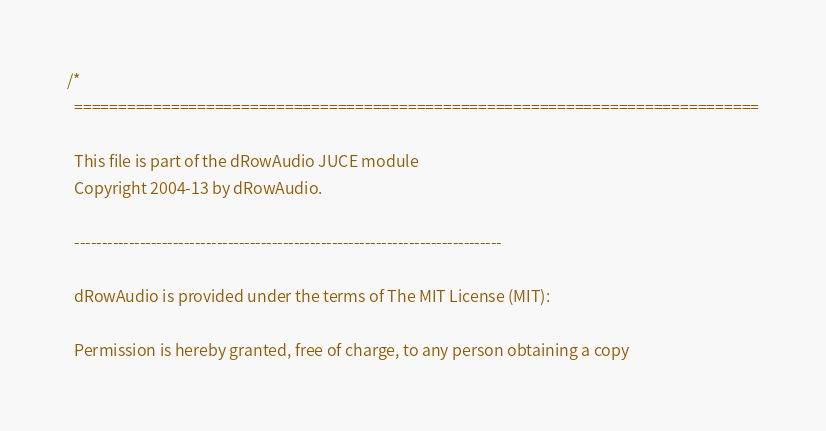<code> <loc_0><loc_0><loc_500><loc_500><_C++_>/*
  ==============================================================================

  This file is part of the dRowAudio JUCE module
  Copyright 2004-13 by dRowAudio.

  ------------------------------------------------------------------------------

  dRowAudio is provided under the terms of The MIT License (MIT):

  Permission is hereby granted, free of charge, to any person obtaining a copy</code> 